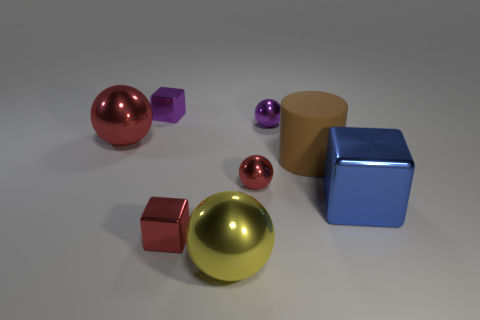Are there any other things that have the same material as the brown cylinder?
Offer a terse response. No. There is a red cube that is the same material as the big yellow thing; what size is it?
Ensure brevity in your answer.  Small. What number of other red things have the same shape as the big red shiny thing?
Give a very brief answer. 1. What number of red cubes are there?
Provide a succinct answer. 1. There is a tiny red shiny object to the right of the yellow ball; is its shape the same as the brown rubber thing?
Ensure brevity in your answer.  No. There is another ball that is the same size as the purple metallic ball; what is it made of?
Your answer should be very brief. Metal. Are there any red objects that have the same material as the big cylinder?
Ensure brevity in your answer.  No. Is the shape of the large yellow object the same as the small purple object in front of the purple metal cube?
Your answer should be compact. Yes. What number of large things are both on the left side of the brown thing and on the right side of the large yellow ball?
Your answer should be very brief. 0. Is the material of the big cube the same as the big object in front of the red metal cube?
Offer a terse response. Yes. 